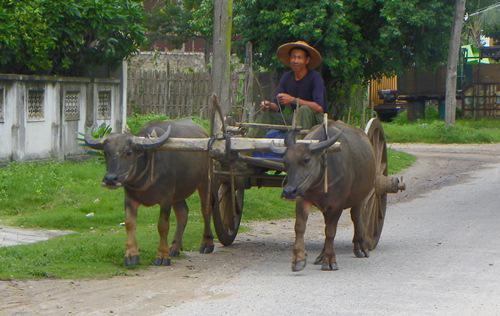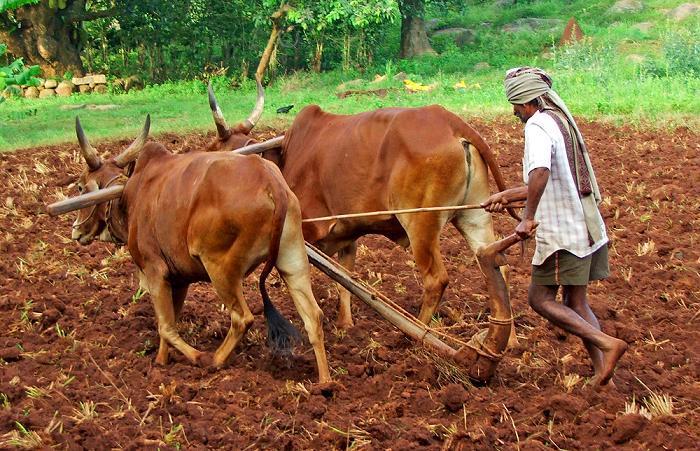The first image is the image on the left, the second image is the image on the right. Considering the images on both sides, is "One image shows two oxen pulling a two-wheeled cart forward on a road, and the other image shows a man standing behind a team of two oxen pulling a plow on a dirt-turned field." valid? Answer yes or no. Yes. The first image is the image on the left, the second image is the image on the right. Examine the images to the left and right. Is the description "Ox are pulling a cart with wheels." accurate? Answer yes or no. Yes. 